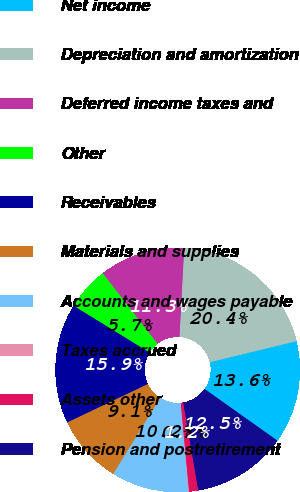<chart> <loc_0><loc_0><loc_500><loc_500><pie_chart><fcel>Net income<fcel>Depreciation and amortization<fcel>Deferred income taxes and<fcel>Other<fcel>Receivables<fcel>Materials and supplies<fcel>Accounts and wages payable<fcel>Taxes accrued<fcel>Assets other<fcel>Pension and postretirement<nl><fcel>13.61%<fcel>20.37%<fcel>11.35%<fcel>5.72%<fcel>15.86%<fcel>9.1%<fcel>10.23%<fcel>0.09%<fcel>1.21%<fcel>12.48%<nl></chart> 